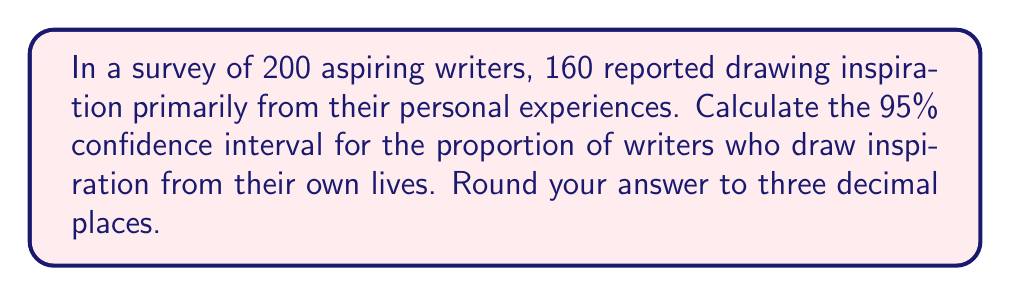Solve this math problem. Let's approach this step-by-step:

1) First, we need to calculate the sample proportion:
   $\hat{p} = \frac{\text{number of successes}}{\text{total sample size}} = \frac{160}{200} = 0.8$

2) The formula for the confidence interval is:
   $$\hat{p} \pm z_{\alpha/2} \sqrt{\frac{\hat{p}(1-\hat{p})}{n}}$$
   where $z_{\alpha/2}$ is the critical value for the desired confidence level.

3) For a 95% confidence interval, $z_{\alpha/2} = 1.96$

4) Now, let's substitute our values:
   $n = 200$
   $\hat{p} = 0.8$

5) Calculate the standard error:
   $$SE = \sqrt{\frac{\hat{p}(1-\hat{p})}{n}} = \sqrt{\frac{0.8(1-0.8)}{200}} = \sqrt{\frac{0.16}{200}} = 0.0283$$

6) Now we can calculate the margin of error:
   $$ME = z_{\alpha/2} * SE = 1.96 * 0.0283 = 0.0555$$

7) Finally, we can compute the confidence interval:
   Lower bound: $0.8 - 0.0555 = 0.7445$
   Upper bound: $0.8 + 0.0555 = 0.8555$

8) Rounding to three decimal places:
   (0.745, 0.856)
Answer: (0.745, 0.856) 